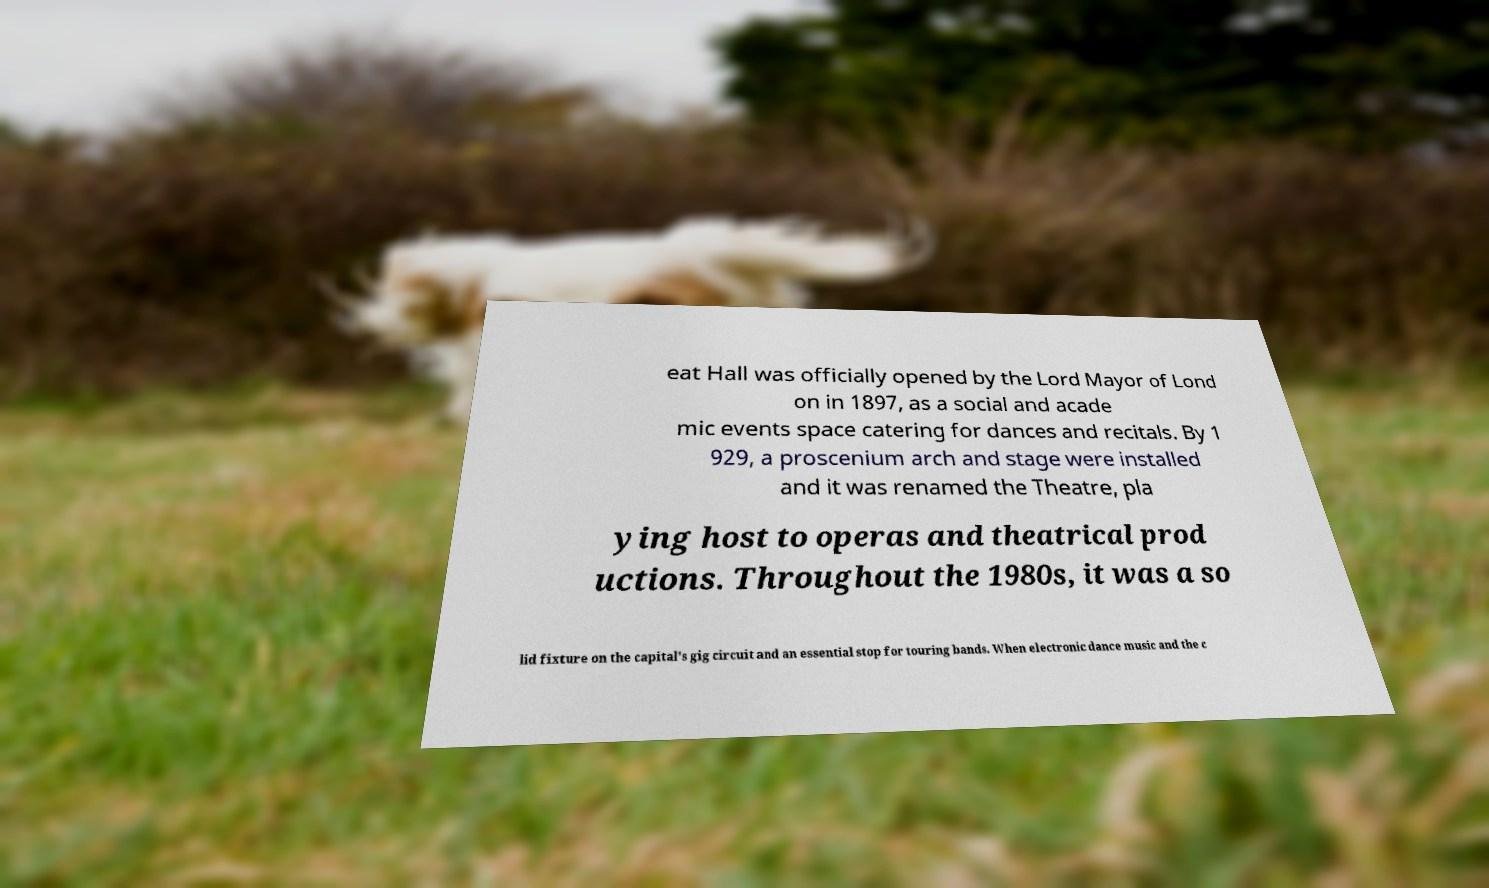For documentation purposes, I need the text within this image transcribed. Could you provide that? eat Hall was officially opened by the Lord Mayor of Lond on in 1897, as a social and acade mic events space catering for dances and recitals. By 1 929, a proscenium arch and stage were installed and it was renamed the Theatre, pla ying host to operas and theatrical prod uctions. Throughout the 1980s, it was a so lid fixture on the capital's gig circuit and an essential stop for touring bands. When electronic dance music and the c 